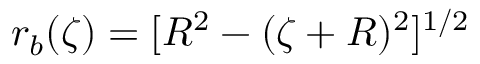Convert formula to latex. <formula><loc_0><loc_0><loc_500><loc_500>r _ { b } ( \zeta ) = [ R ^ { 2 } - ( \zeta + R ) ^ { 2 } ] ^ { 1 / 2 }</formula> 